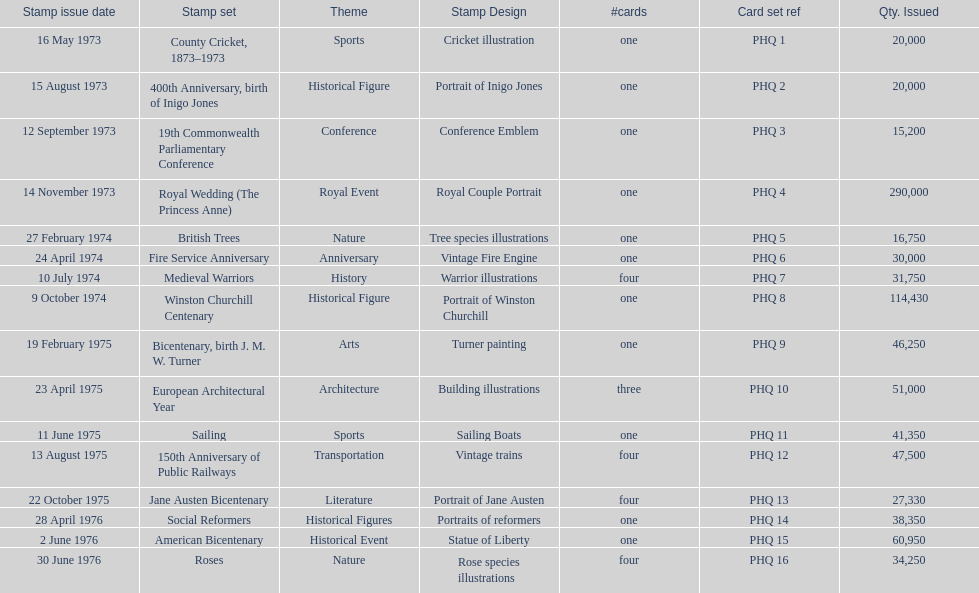How many stamp sets were released in the year 1975? 5. 